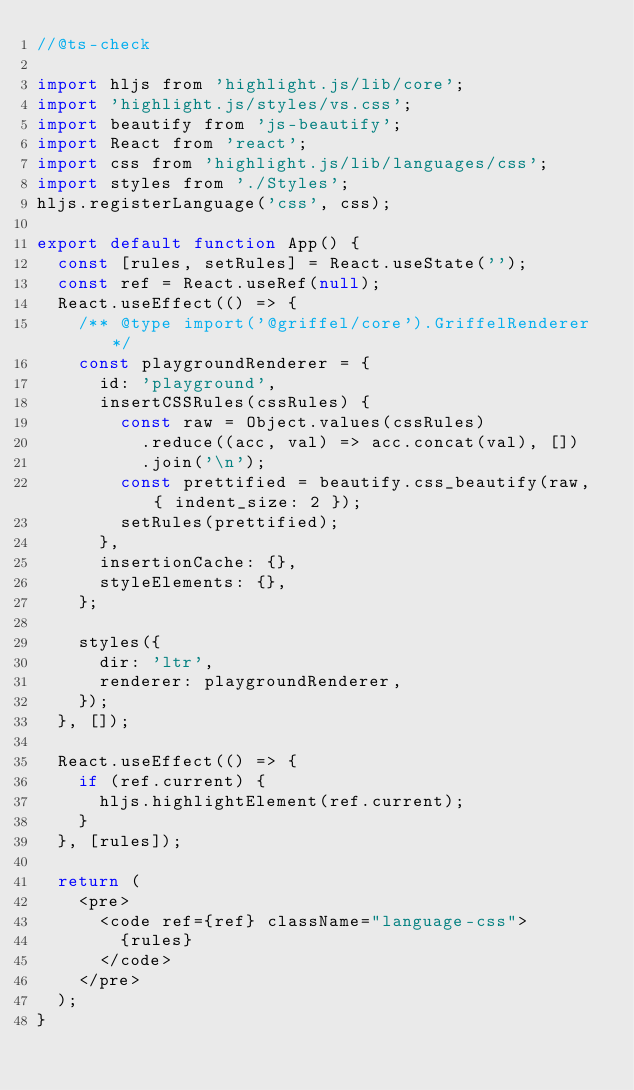<code> <loc_0><loc_0><loc_500><loc_500><_JavaScript_>//@ts-check

import hljs from 'highlight.js/lib/core';
import 'highlight.js/styles/vs.css';
import beautify from 'js-beautify';
import React from 'react';
import css from 'highlight.js/lib/languages/css';
import styles from './Styles';
hljs.registerLanguage('css', css);

export default function App() {
  const [rules, setRules] = React.useState('');
  const ref = React.useRef(null);
  React.useEffect(() => {
    /** @type import('@griffel/core').GriffelRenderer */
    const playgroundRenderer = {
      id: 'playground',
      insertCSSRules(cssRules) {
        const raw = Object.values(cssRules)
          .reduce((acc, val) => acc.concat(val), [])
          .join('\n');
        const prettified = beautify.css_beautify(raw, { indent_size: 2 });
        setRules(prettified);
      },
      insertionCache: {},
      styleElements: {},
    };

    styles({
      dir: 'ltr',
      renderer: playgroundRenderer,
    });
  }, []);

  React.useEffect(() => {
    if (ref.current) {
      hljs.highlightElement(ref.current);
    }
  }, [rules]);

  return (
    <pre>
      <code ref={ref} className="language-css">
        {rules}
      </code>
    </pre>
  );
}
</code> 